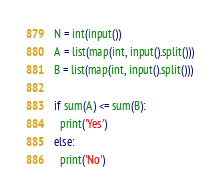Convert code to text. <code><loc_0><loc_0><loc_500><loc_500><_Python_>N = int(input())
A = list(map(int, input().split()))
B = list(map(int, input().split()))

if sum(A) <= sum(B):
  print('Yes')
else:
  print('No')</code> 